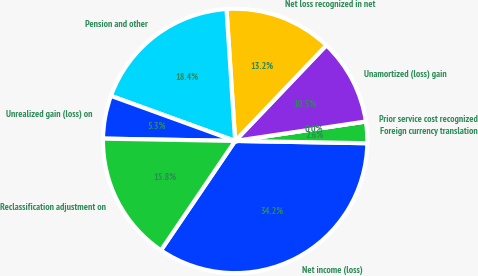Convert chart. <chart><loc_0><loc_0><loc_500><loc_500><pie_chart><fcel>Net income (loss)<fcel>Foreign currency translation<fcel>Prior service cost recognized<fcel>Unamortized (loss) gain<fcel>Net loss recognized in net<fcel>Pension and other<fcel>Unrealized gain (loss) on<fcel>Reclassification adjustment on<nl><fcel>34.21%<fcel>2.63%<fcel>0.0%<fcel>10.53%<fcel>13.16%<fcel>18.42%<fcel>5.26%<fcel>15.79%<nl></chart> 